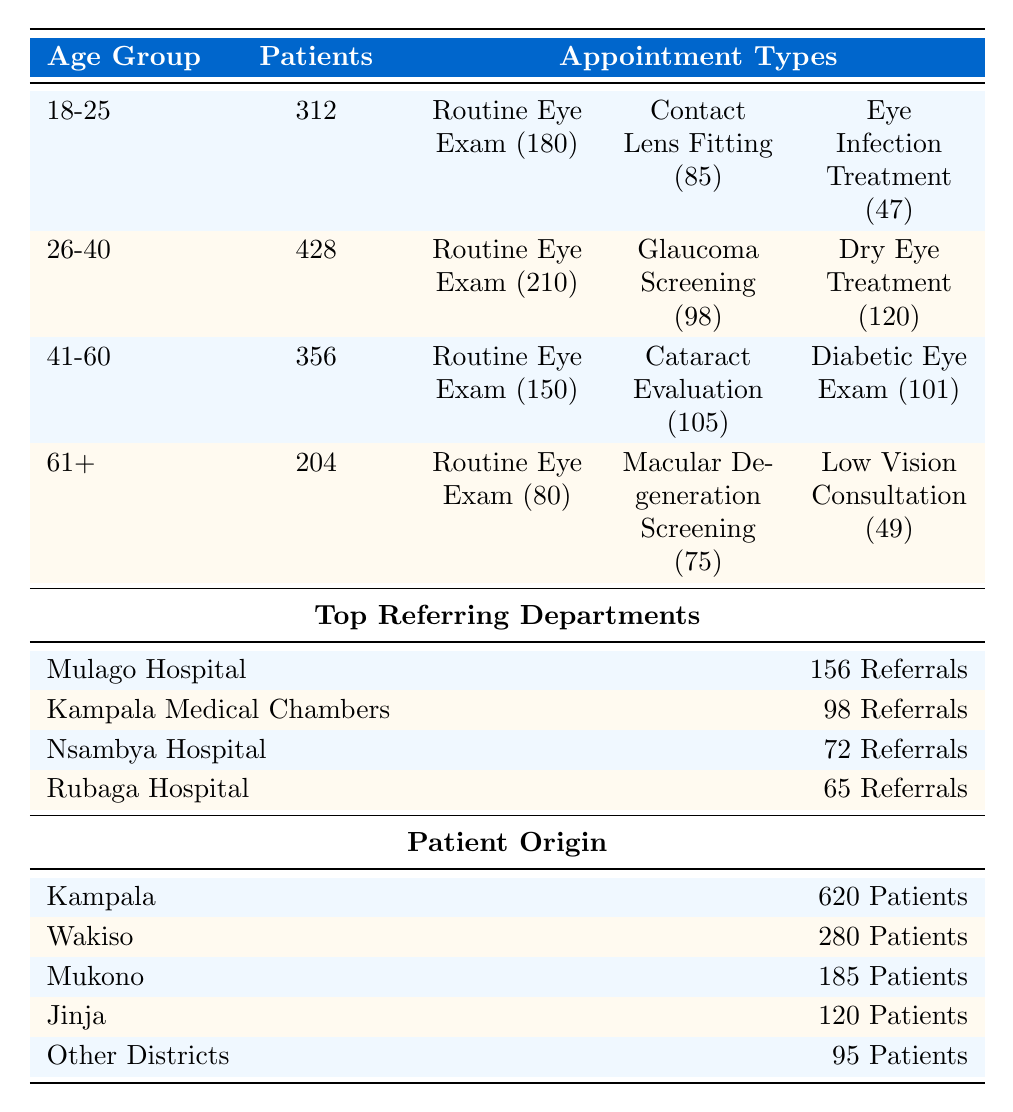What is the total number of patients in the age group 26-40? The table lists 428 patients in the age group 26-40.
Answer: 428 How many patients are referred by Mulago Hospital? According to the table, Mulago Hospital has referred 156 patients.
Answer: 156 What is the count of Routine Eye Exam appointments for the age group 41-60? The table shows that there are 150 Routine Eye Exam appointments in the 41-60 age group.
Answer: 150 Which appointment type has the highest count for the age group 18-25? In the age group 18-25, the highest count appointment type is Routine Eye Exam with 180 counts.
Answer: Routine Eye Exam Are there more patients referred by Kampala Medical Chambers or Nsambya Hospital? Kampala Medical Chambers has 98 referrals while Nsambya Hospital has 72, so there are more referrals from Kampala Medical Chambers.
Answer: Yes What is the total count of referrals from the top three departments? Adding the referrals from the three top departments: 156 (Mulago) + 98 (Kampala Medical Chambers) + 72 (Nsambya) = 326.
Answer: 326 What is the average number of patients across all age groups? The total number of patients is 312 + 428 + 356 + 204 = 1300, and there are 4 age groups, so the average is 1300/4 = 325.
Answer: 325 Which age group has the least number of patients? The age group 61+ has the least number of patients at 204.
Answer: 61+ How many appointments for Dry Eye Treatment were made by patients aged 26-40? For the age group 26-40, there were 120 appointments for Dry Eye Treatment.
Answer: 120 What percentage of the total patients come from Kampala? Kampala has 620 patients, and the total number of patients is 1300, so the percentage is (620/1300) * 100 ≈ 47.69%.
Answer: 47.69% Which appointment type is most common across all age groups? The most common appointment type across all age groups is Routine Eye Exam, with counts of 180, 210, 150, and 80, totaling 620 appointments.
Answer: Routine Eye Exam 